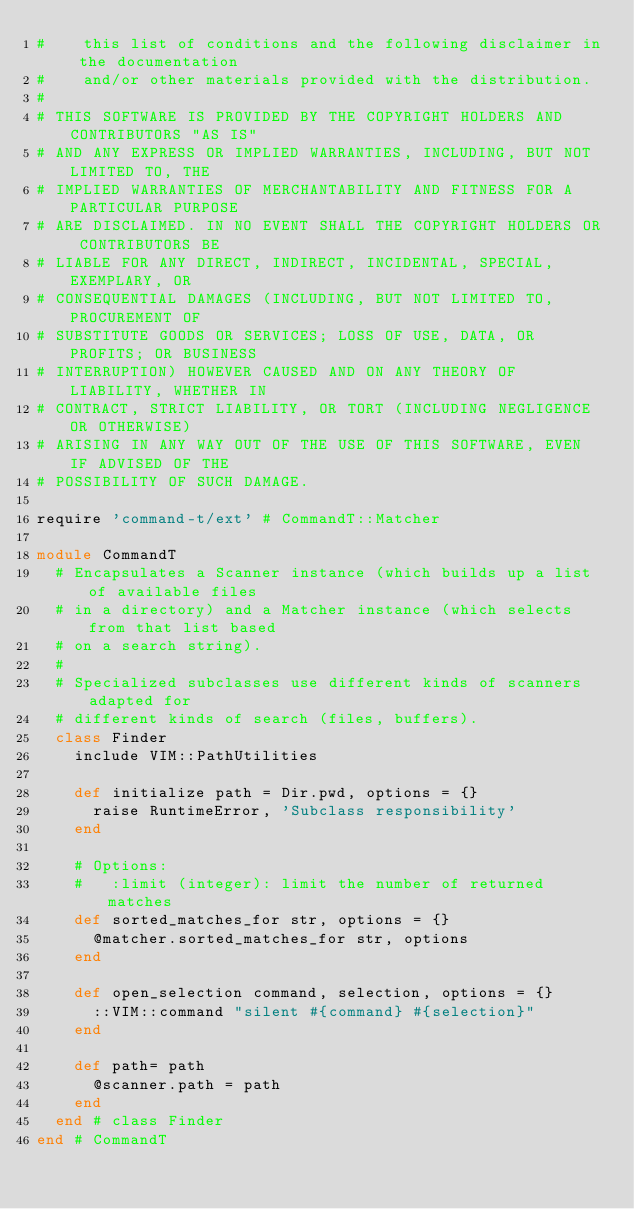<code> <loc_0><loc_0><loc_500><loc_500><_Ruby_>#    this list of conditions and the following disclaimer in the documentation
#    and/or other materials provided with the distribution.
#
# THIS SOFTWARE IS PROVIDED BY THE COPYRIGHT HOLDERS AND CONTRIBUTORS "AS IS"
# AND ANY EXPRESS OR IMPLIED WARRANTIES, INCLUDING, BUT NOT LIMITED TO, THE
# IMPLIED WARRANTIES OF MERCHANTABILITY AND FITNESS FOR A PARTICULAR PURPOSE
# ARE DISCLAIMED. IN NO EVENT SHALL THE COPYRIGHT HOLDERS OR CONTRIBUTORS BE
# LIABLE FOR ANY DIRECT, INDIRECT, INCIDENTAL, SPECIAL, EXEMPLARY, OR
# CONSEQUENTIAL DAMAGES (INCLUDING, BUT NOT LIMITED TO, PROCUREMENT OF
# SUBSTITUTE GOODS OR SERVICES; LOSS OF USE, DATA, OR PROFITS; OR BUSINESS
# INTERRUPTION) HOWEVER CAUSED AND ON ANY THEORY OF LIABILITY, WHETHER IN
# CONTRACT, STRICT LIABILITY, OR TORT (INCLUDING NEGLIGENCE OR OTHERWISE)
# ARISING IN ANY WAY OUT OF THE USE OF THIS SOFTWARE, EVEN IF ADVISED OF THE
# POSSIBILITY OF SUCH DAMAGE.

require 'command-t/ext' # CommandT::Matcher

module CommandT
  # Encapsulates a Scanner instance (which builds up a list of available files
  # in a directory) and a Matcher instance (which selects from that list based
  # on a search string).
  #
  # Specialized subclasses use different kinds of scanners adapted for
  # different kinds of search (files, buffers).
  class Finder
    include VIM::PathUtilities

    def initialize path = Dir.pwd, options = {}
      raise RuntimeError, 'Subclass responsibility'
    end

    # Options:
    #   :limit (integer): limit the number of returned matches
    def sorted_matches_for str, options = {}
      @matcher.sorted_matches_for str, options
    end

    def open_selection command, selection, options = {}
      ::VIM::command "silent #{command} #{selection}"
    end

    def path= path
      @scanner.path = path
    end
  end # class Finder
end # CommandT
</code> 